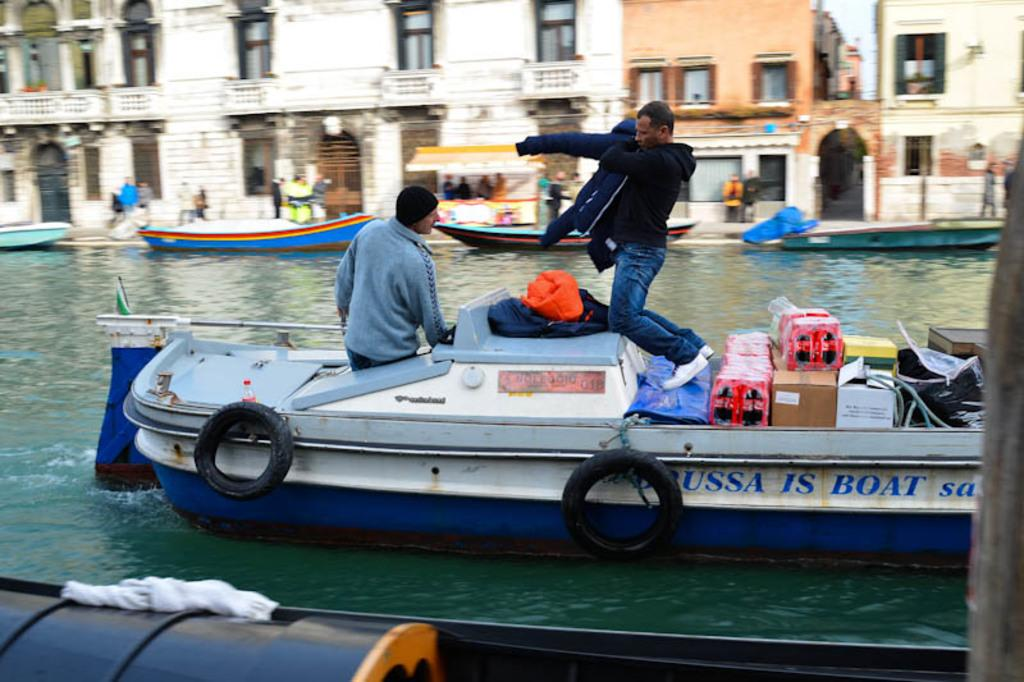What is the main subject in the center of the image? There are boats in the center of the image. Who or what is inside the boats? There are people in the boats. What is visible at the bottom of the image? Water is visible at the bottom of the image. What can be seen in the background of the image? There are buildings in the background of the image. What type of stamp can be seen on the kitten in the image? There is no kitten or stamp present in the image. Is there any steam coming from the boats in the image? There is no steam visible in the image; only boats, people, water, and buildings are present. 